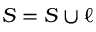Convert formula to latex. <formula><loc_0><loc_0><loc_500><loc_500>S = S \cup \ell</formula> 